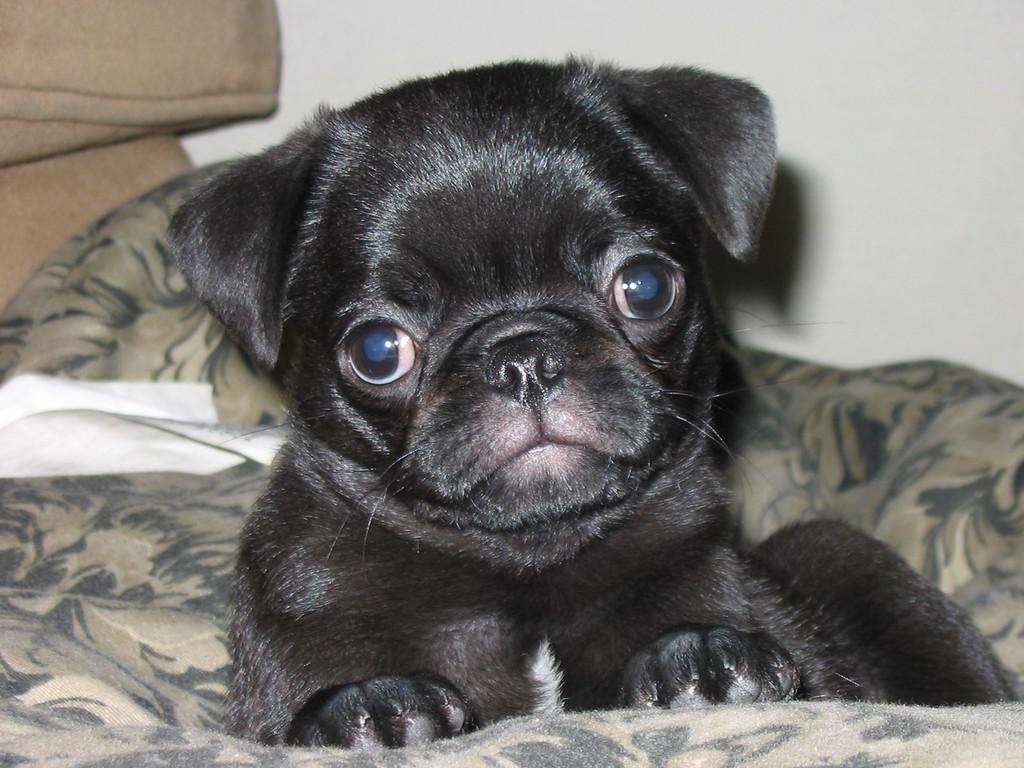Describe this image in one or two sentences. As we can see in the image there is a white color wall and black color cat sitting on sofa. 